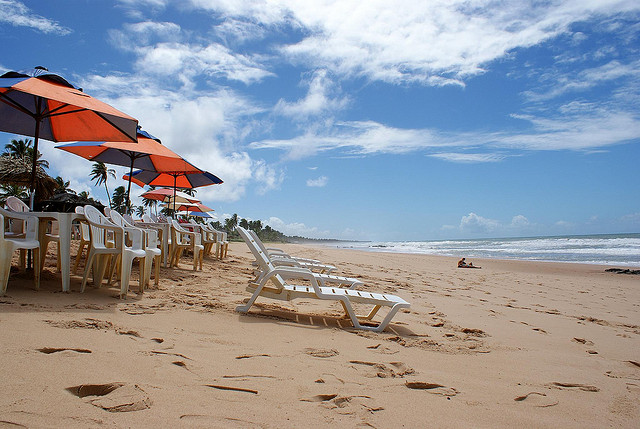What activities might people do at this beach? People might enjoy sunbathing, swimming, beach volleyball, building sandcastles, or simply relaxing and reading a book under one of those colorful beach umbrellas. Are there any amenities nearby on this beach? Given the presence of lined-up beach chairs and umbrellas, there are likely amenities such as a rental kiosk for beach equipment, nearby cafes or snack bars, and possibly showering facilities. 